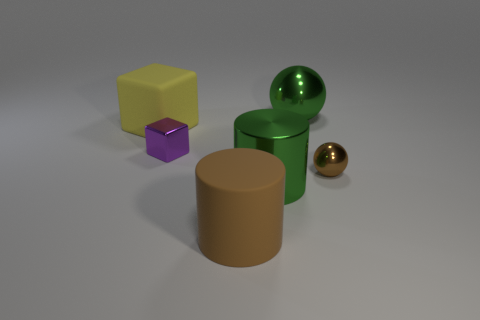What is the shape of the big green metal object behind the green object in front of the small object that is to the right of the large brown cylinder? The shape of the big green metal object situated behind the smaller green object and to the left of the large brown cylinder is that of a sphere—perfectly round and symmetrical. 